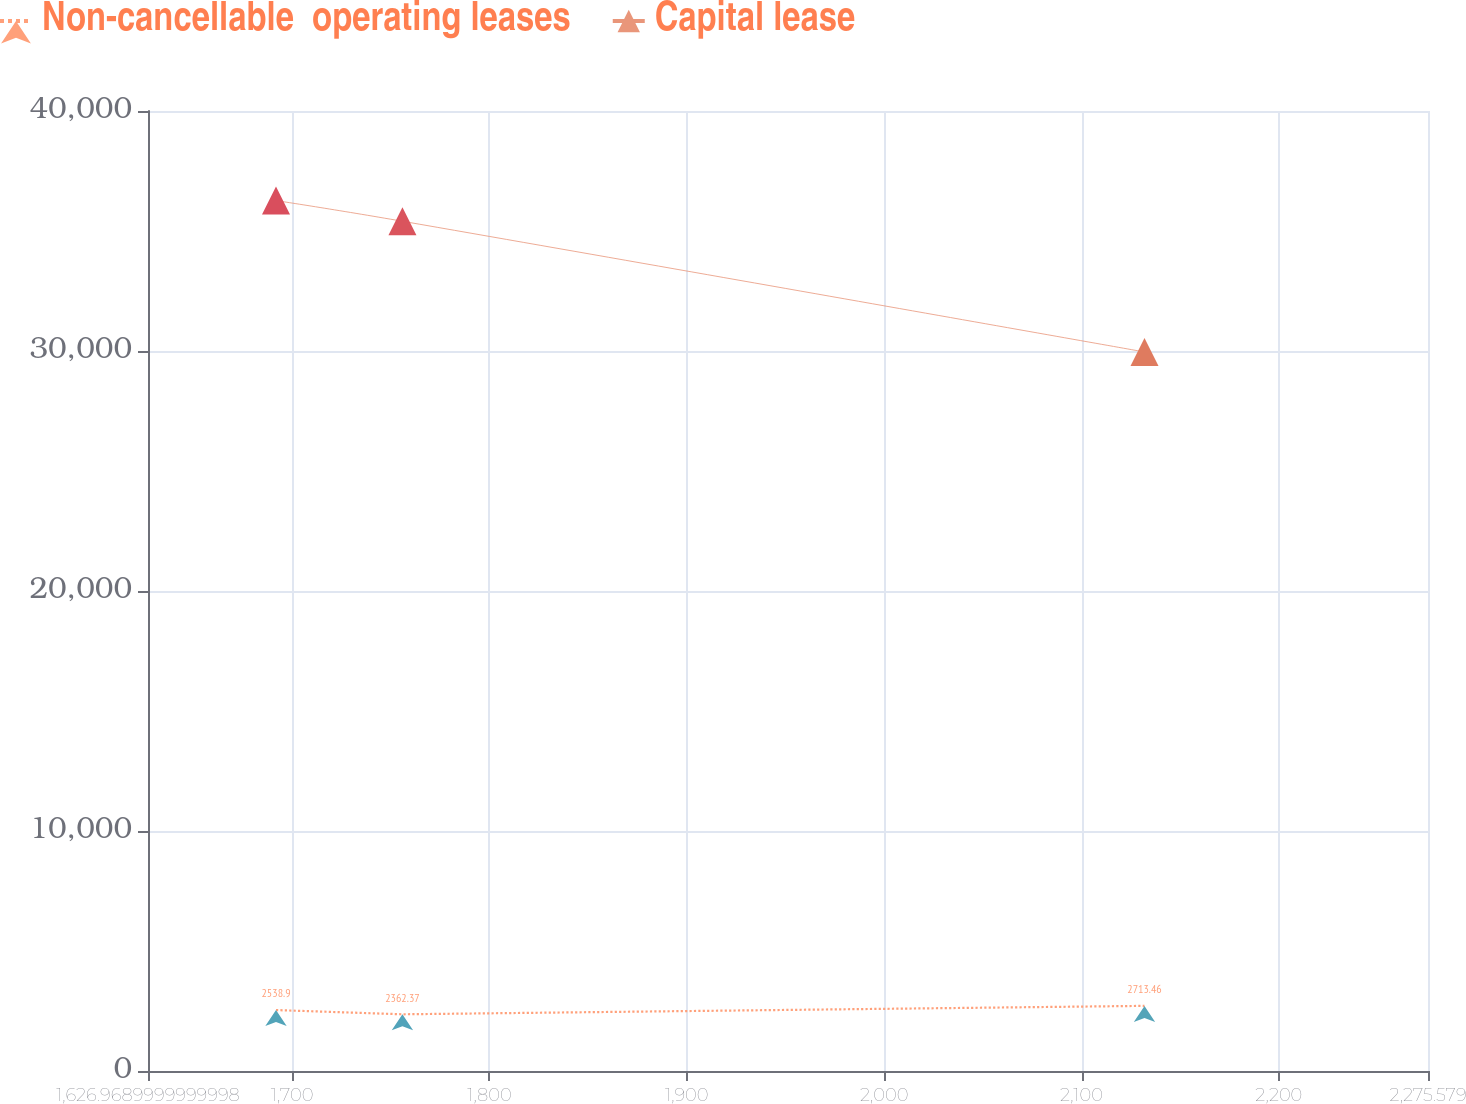Convert chart. <chart><loc_0><loc_0><loc_500><loc_500><line_chart><ecel><fcel>Non-cancellable  operating leases<fcel>Capital lease<nl><fcel>1691.83<fcel>2538.9<fcel>36268.2<nl><fcel>1755.89<fcel>2362.37<fcel>35406.6<nl><fcel>2131.92<fcel>2713.46<fcel>29960.9<nl><fcel>2280.66<fcel>2837.6<fcel>33181.1<nl><fcel>2340.44<fcel>2277.28<fcel>28724.5<nl></chart> 